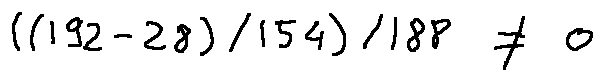Convert formula to latex. <formula><loc_0><loc_0><loc_500><loc_500>( ( 1 9 2 - 2 8 ) / 1 5 4 ) / 1 8 8 \neq 0</formula> 